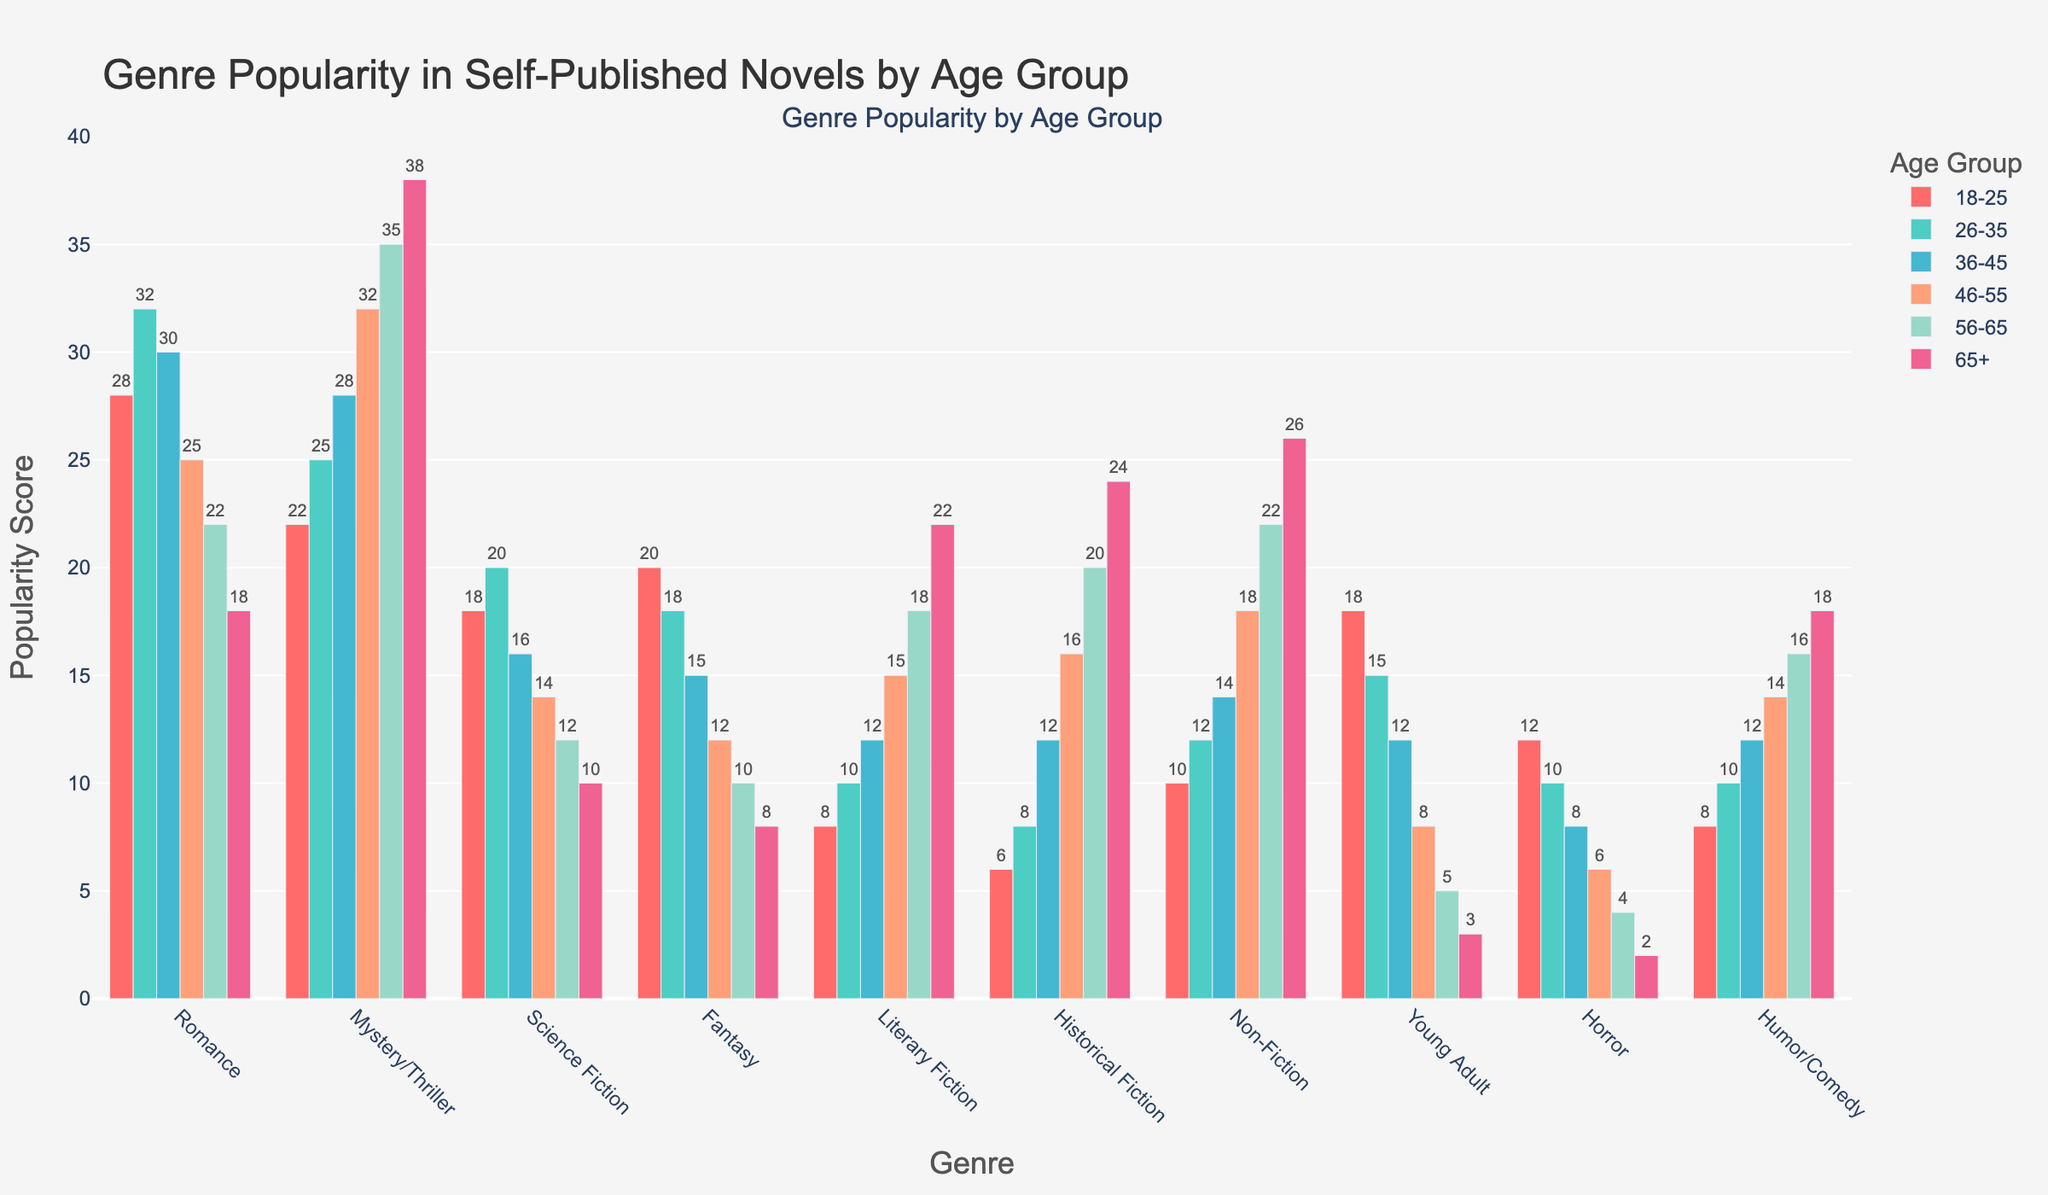Which genre is most popular among the 18-25 age group? Look at the heights of the bars representing each genre for the 18-25 age group and identify the tallest one. Romance has the tallest bar.
Answer: Romance Which genre has a declining popularity trend as the age group increases? Observe the charts across all age groups for each genre and note which genre's bar heights consistently decrease as age increases. Young Adult shows a decline.
Answer: Young Adult Which genre shows the highest popularity for the 46-55 age group? Compare the bar heights for all genres within the 46-55 age group. Mystery/Thriller has the highest bar.
Answer: Mystery/Thriller How does the popularity of Historical Fiction change from the 18-25 age group to the 65+ age group? Track the Historical Fiction bar heights across each age group. It starts at 6 and increases progressively to 24.
Answer: Increases Which two genres show a close number of popularity points for the 26-35 age group? Identify which pair of genres have bars of similar height for the 26-35 age group. Romance (32) and Mystery/Thriller (25) are close.
Answer: Romance and Mystery/Thriller Calculate the average popularity score for Fantasy across all age groups. Add the popularity values of Fantasy across all age groups: (20+18+15+12+10+8). Then divide by 6. The calculations are (20+18+15+12+10+8)/6 = 13.83.
Answer: 13.83 Which genre is less popular among the 56-65 age group compared to the 46-55 age group? Identify the genres by comparing their bar heights for the 56-65 and 46-55 age groups and noting where the heights decrease. Romance decreases from 25 to 22.
Answer: Romance How does the popularity of Non-Fiction change as age increases? Track the Non-Fiction bars' heights for each age group. It consistently increases from 10 to 26 as age progresses.
Answer: Increases Compare the popularity of Horror and Humor/Comedy for the 65+ age group. Assess the bar heights for Horror and Humor/Comedy in the 65+ age group. Humor/Comedy is taller with a value of 18 compared to Horror's 2.
Answer: Humor/Comedy What's the total popularity score of Science Fiction and Fantasy for the 36-45 age group? Sum the values of Science Fiction (16) and Fantasy (15) for the 36-45 age group. The calculation is 16 + 15 = 31.
Answer: 31 